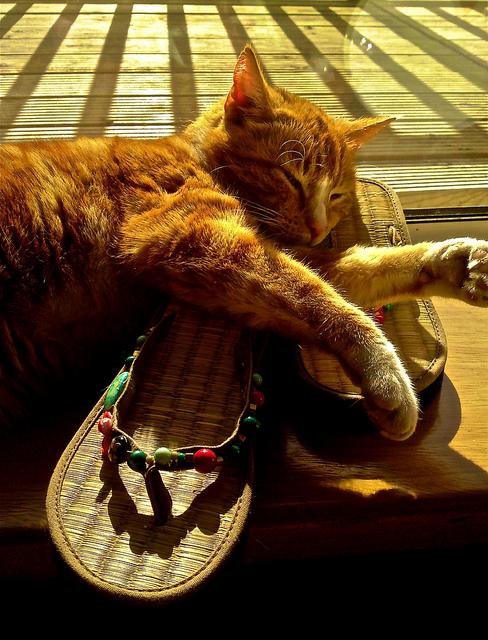What kind of shoes is the cat lying on?
Be succinct. Sandals. What color is the animal?
Write a very short answer. Orange. Is the cat outside?
Quick response, please. No. 